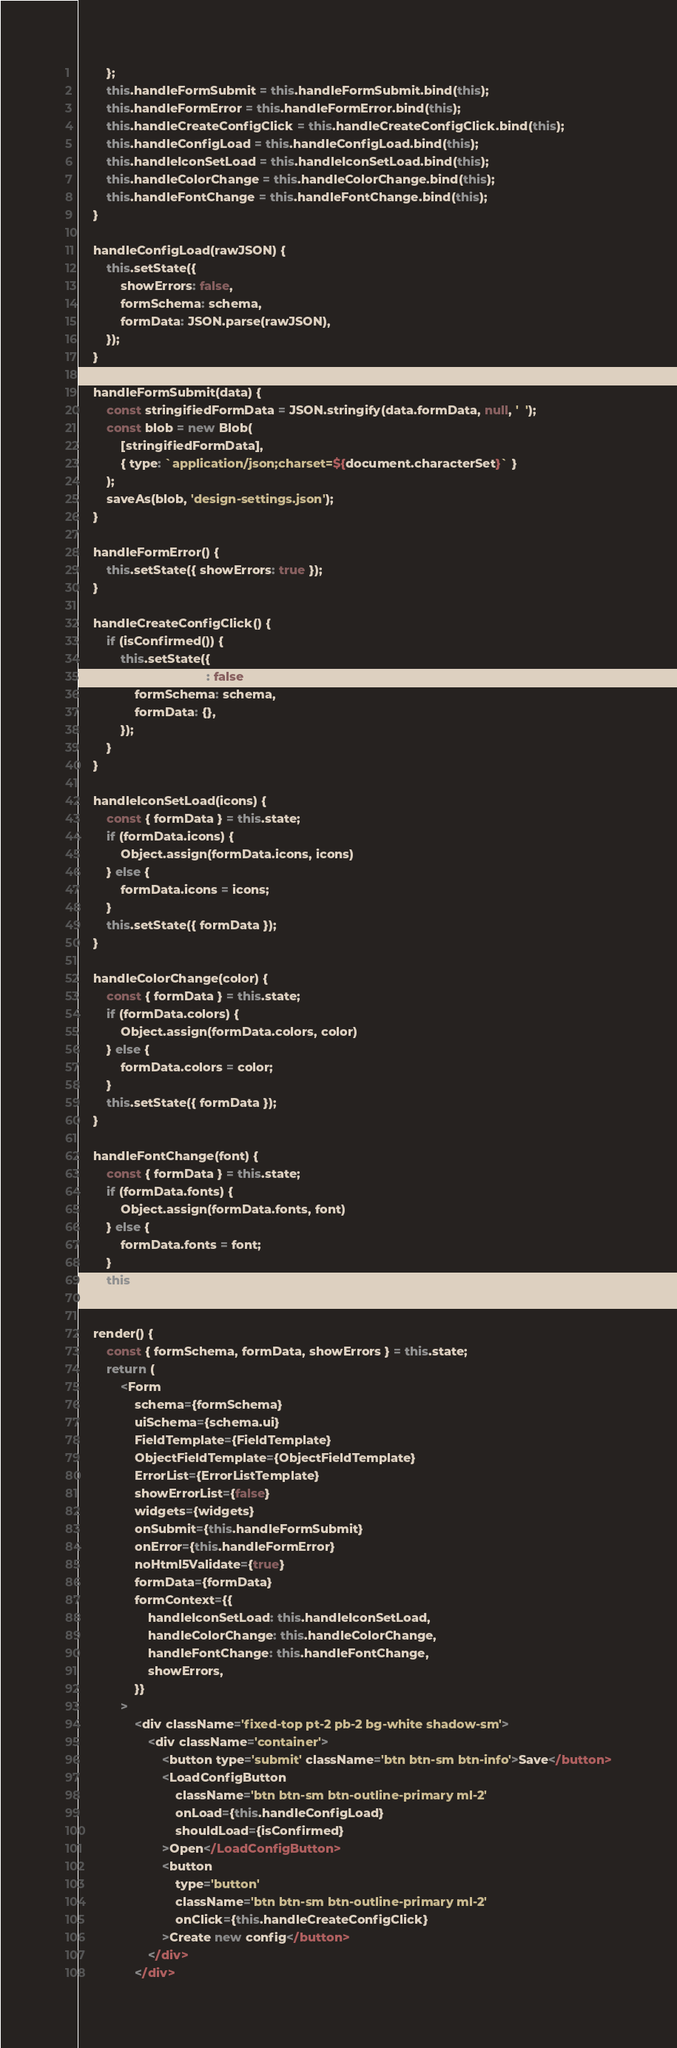Convert code to text. <code><loc_0><loc_0><loc_500><loc_500><_JavaScript_>        };
        this.handleFormSubmit = this.handleFormSubmit.bind(this);
        this.handleFormError = this.handleFormError.bind(this);
        this.handleCreateConfigClick = this.handleCreateConfigClick.bind(this);
        this.handleConfigLoad = this.handleConfigLoad.bind(this);
        this.handleIconSetLoad = this.handleIconSetLoad.bind(this);
        this.handleColorChange = this.handleColorChange.bind(this);
        this.handleFontChange = this.handleFontChange.bind(this);
    }

    handleConfigLoad(rawJSON) {
        this.setState({
            showErrors: false,
            formSchema: schema,
            formData: JSON.parse(rawJSON),
        });
    }

    handleFormSubmit(data) {
        const stringifiedFormData = JSON.stringify(data.formData, null, '  ');
        const blob = new Blob(
            [stringifiedFormData],
            { type: `application/json;charset=${document.characterSet}` }
        );
        saveAs(blob, 'design-settings.json');
    }

    handleFormError() {
        this.setState({ showErrors: true });
    }

    handleCreateConfigClick() {
        if (isConfirmed()) {
            this.setState({
                showErrors: false,
                formSchema: schema,
                formData: {},
            });
        }
    }

    handleIconSetLoad(icons) {
        const { formData } = this.state;
        if (formData.icons) {
            Object.assign(formData.icons, icons)
        } else {
            formData.icons = icons;
        }
        this.setState({ formData });
    }

    handleColorChange(color) {
        const { formData } = this.state;
        if (formData.colors) {
            Object.assign(formData.colors, color)
        } else {
            formData.colors = color;
        }
        this.setState({ formData });
    }

    handleFontChange(font) {
        const { formData } = this.state;
        if (formData.fonts) {
            Object.assign(formData.fonts, font)
        } else {
            formData.fonts = font;
        }
        this.setState({ formData });
    }

    render() {
        const { formSchema, formData, showErrors } = this.state;
        return (
            <Form
                schema={formSchema}
                uiSchema={schema.ui}
                FieldTemplate={FieldTemplate}
                ObjectFieldTemplate={ObjectFieldTemplate}
                ErrorList={ErrorListTemplate}
                showErrorList={false}
                widgets={widgets}
                onSubmit={this.handleFormSubmit}
                onError={this.handleFormError}
                noHtml5Validate={true}
                formData={formData}
                formContext={{
                    handleIconSetLoad: this.handleIconSetLoad,
                    handleColorChange: this.handleColorChange,
                    handleFontChange: this.handleFontChange,
                    showErrors,
                }}
            >
                <div className='fixed-top pt-2 pb-2 bg-white shadow-sm'>
                    <div className='container'>
                        <button type='submit' className='btn btn-sm btn-info'>Save</button>
                        <LoadConfigButton
                            className='btn btn-sm btn-outline-primary ml-2'
                            onLoad={this.handleConfigLoad}
                            shouldLoad={isConfirmed}
                        >Open</LoadConfigButton>
                        <button
                            type='button'
                            className='btn btn-sm btn-outline-primary ml-2'
                            onClick={this.handleCreateConfigClick}
                        >Create new config</button>
                    </div>
                </div></code> 